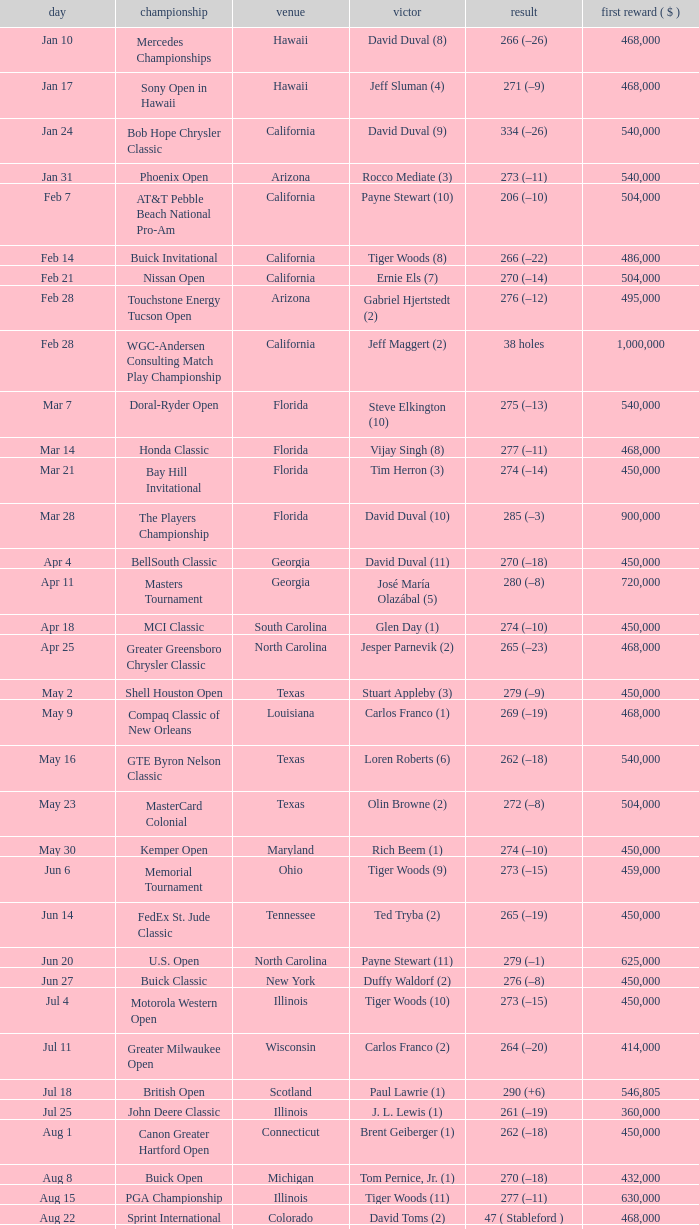Who is the winner of the tournament in Georgia on Oct 3? David Toms (3). 